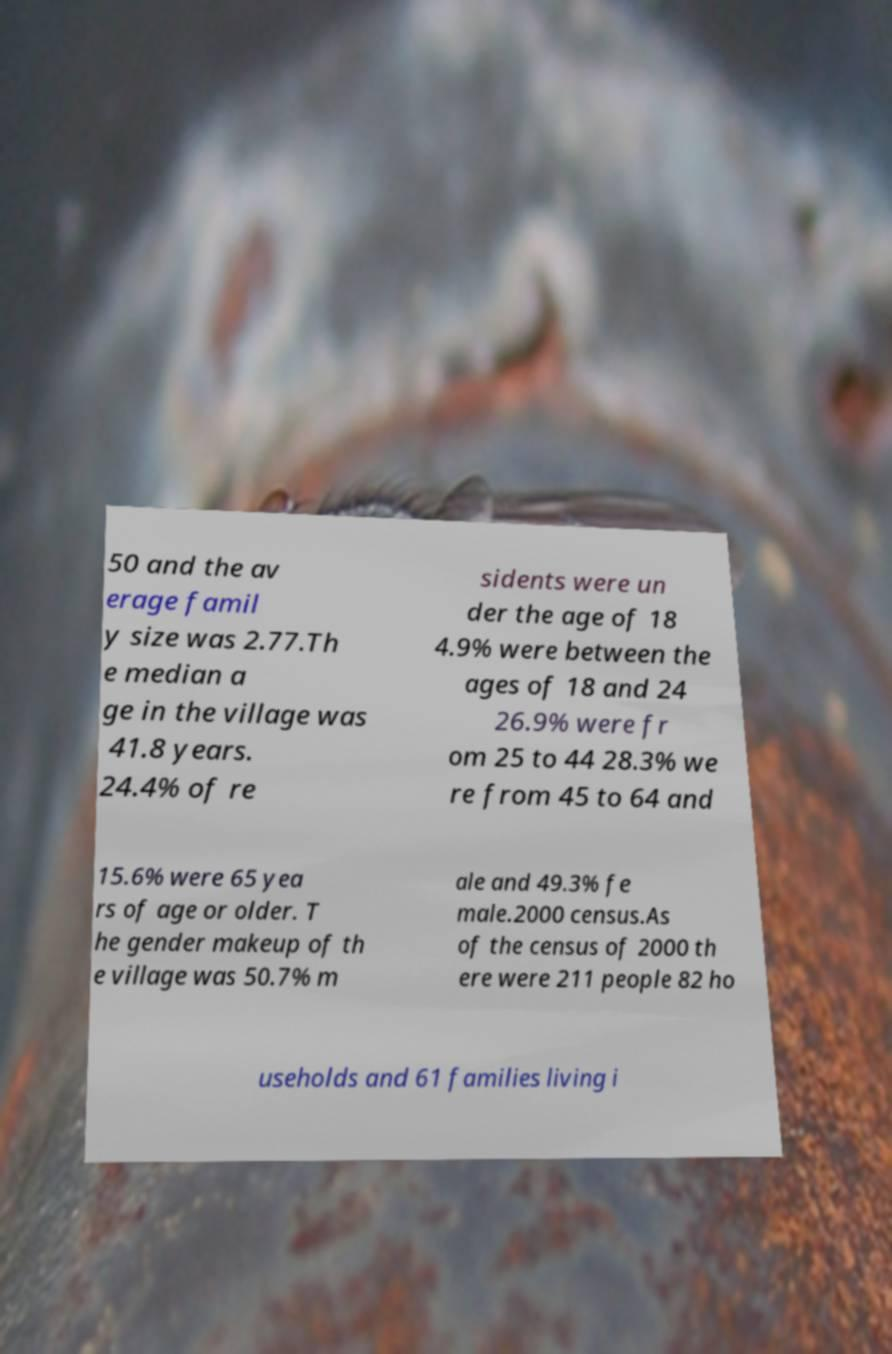Could you assist in decoding the text presented in this image and type it out clearly? 50 and the av erage famil y size was 2.77.Th e median a ge in the village was 41.8 years. 24.4% of re sidents were un der the age of 18 4.9% were between the ages of 18 and 24 26.9% were fr om 25 to 44 28.3% we re from 45 to 64 and 15.6% were 65 yea rs of age or older. T he gender makeup of th e village was 50.7% m ale and 49.3% fe male.2000 census.As of the census of 2000 th ere were 211 people 82 ho useholds and 61 families living i 